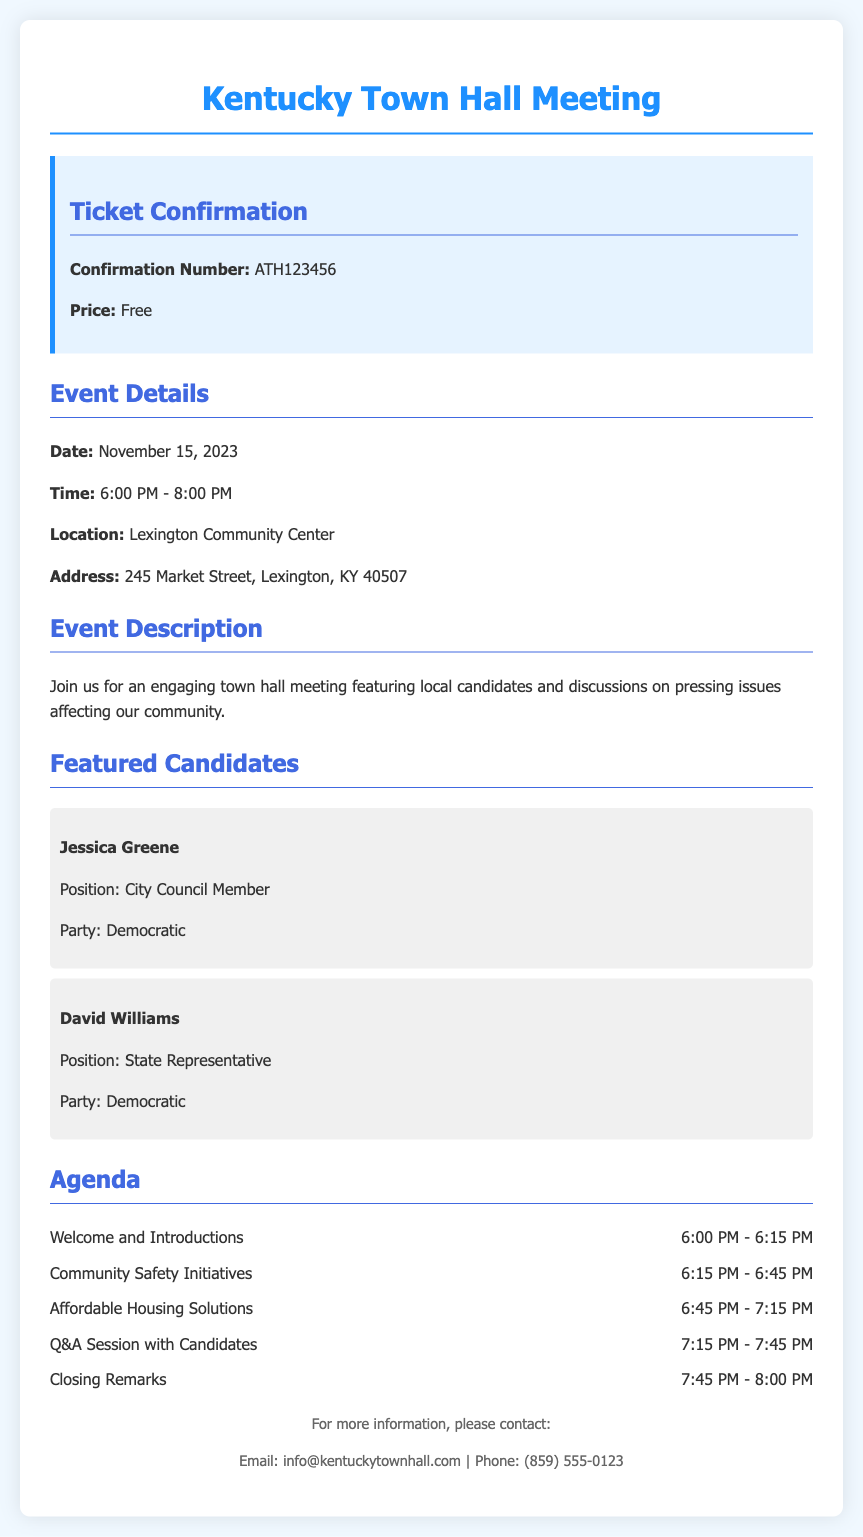What is the confirmation number? The confirmation number is stated in the ticket confirmation section of the document.
Answer: ATH123456 What is the date of the town hall meeting? The date is clearly mentioned under the event details section.
Answer: November 15, 2023 Where is the meeting location? The meeting location is specified in the event details section of the document.
Answer: Lexington Community Center What are the featured candidates' political parties? The document indicates the political party of each featured candidate.
Answer: Democratic What time does the Q&A session with candidates start? The time for the Q&A session is detailed in the agenda section.
Answer: 7:15 PM How long is the community safety initiatives discussion? The duration is indicated in the agenda section, comparing start and end times provides the length.
Answer: 30 minutes What type of event is this document confirming? The document outlines the nature of the event in the event description subsection.
Answer: Town hall meeting What is the price of the ticket? The ticket price is explicitly mentioned in the ticket confirmation section.
Answer: Free 